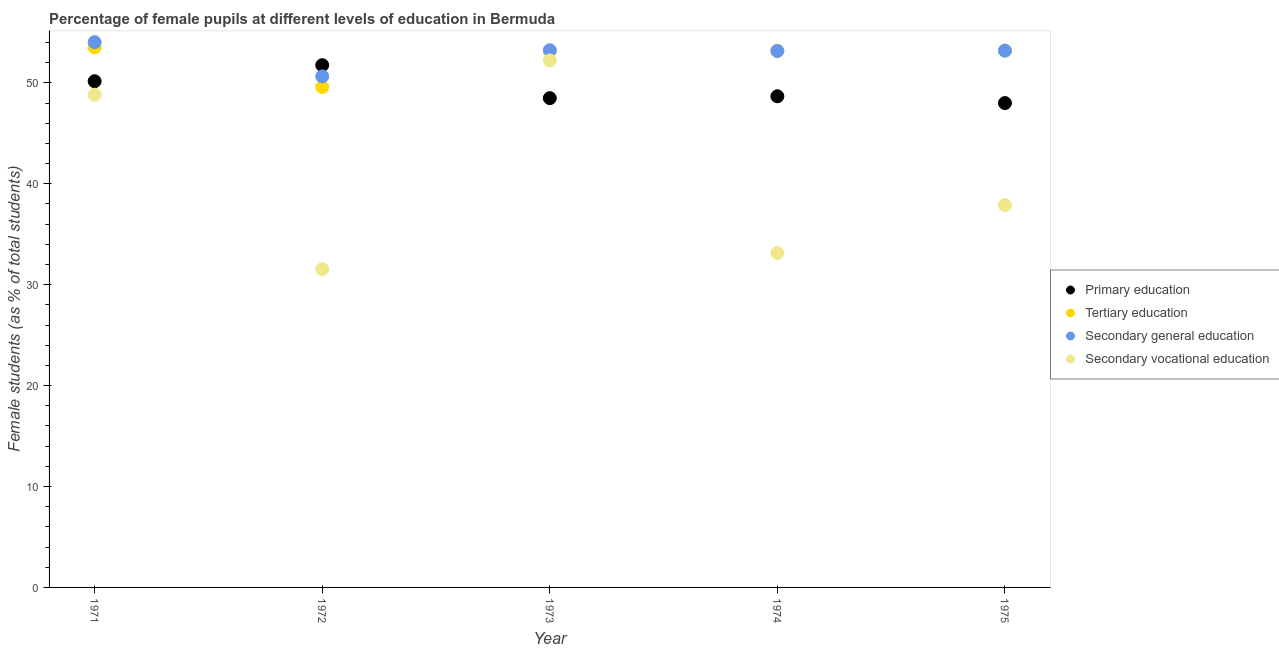How many different coloured dotlines are there?
Offer a terse response. 4. What is the percentage of female students in primary education in 1971?
Your answer should be very brief. 50.16. Across all years, what is the maximum percentage of female students in secondary vocational education?
Your response must be concise. 52.22. Across all years, what is the minimum percentage of female students in tertiary education?
Offer a very short reply. 49.59. In which year was the percentage of female students in secondary vocational education maximum?
Provide a succinct answer. 1973. What is the total percentage of female students in secondary vocational education in the graph?
Provide a short and direct response. 203.61. What is the difference between the percentage of female students in secondary education in 1973 and that in 1975?
Provide a short and direct response. 0.04. What is the difference between the percentage of female students in secondary vocational education in 1972 and the percentage of female students in tertiary education in 1971?
Provide a succinct answer. -21.98. What is the average percentage of female students in tertiary education per year?
Your answer should be very brief. 52.52. In the year 1974, what is the difference between the percentage of female students in secondary vocational education and percentage of female students in primary education?
Keep it short and to the point. -15.52. What is the ratio of the percentage of female students in primary education in 1973 to that in 1975?
Make the answer very short. 1.01. What is the difference between the highest and the second highest percentage of female students in secondary education?
Offer a very short reply. 0.8. What is the difference between the highest and the lowest percentage of female students in primary education?
Your response must be concise. 3.76. In how many years, is the percentage of female students in secondary education greater than the average percentage of female students in secondary education taken over all years?
Your answer should be very brief. 4. Is the sum of the percentage of female students in secondary vocational education in 1972 and 1974 greater than the maximum percentage of female students in primary education across all years?
Provide a succinct answer. Yes. Is the percentage of female students in tertiary education strictly greater than the percentage of female students in primary education over the years?
Offer a terse response. No. Is the percentage of female students in secondary vocational education strictly less than the percentage of female students in tertiary education over the years?
Keep it short and to the point. Yes. How many dotlines are there?
Keep it short and to the point. 4. What is the difference between two consecutive major ticks on the Y-axis?
Offer a terse response. 10. Does the graph contain grids?
Provide a succinct answer. No. How are the legend labels stacked?
Make the answer very short. Vertical. What is the title of the graph?
Your answer should be very brief. Percentage of female pupils at different levels of education in Bermuda. Does "Gender equality" appear as one of the legend labels in the graph?
Your response must be concise. No. What is the label or title of the Y-axis?
Your answer should be very brief. Female students (as % of total students). What is the Female students (as % of total students) of Primary education in 1971?
Ensure brevity in your answer.  50.16. What is the Female students (as % of total students) in Tertiary education in 1971?
Your response must be concise. 53.51. What is the Female students (as % of total students) of Secondary general education in 1971?
Give a very brief answer. 54.03. What is the Female students (as % of total students) of Secondary vocational education in 1971?
Your answer should be very brief. 48.82. What is the Female students (as % of total students) of Primary education in 1972?
Your answer should be compact. 51.75. What is the Female students (as % of total students) in Tertiary education in 1972?
Give a very brief answer. 49.59. What is the Female students (as % of total students) in Secondary general education in 1972?
Give a very brief answer. 50.64. What is the Female students (as % of total students) of Secondary vocational education in 1972?
Your answer should be compact. 31.54. What is the Female students (as % of total students) of Primary education in 1973?
Give a very brief answer. 48.49. What is the Female students (as % of total students) in Tertiary education in 1973?
Ensure brevity in your answer.  53.17. What is the Female students (as % of total students) in Secondary general education in 1973?
Provide a short and direct response. 53.23. What is the Female students (as % of total students) in Secondary vocational education in 1973?
Provide a short and direct response. 52.22. What is the Female students (as % of total students) of Primary education in 1974?
Ensure brevity in your answer.  48.67. What is the Female students (as % of total students) in Tertiary education in 1974?
Give a very brief answer. 53.16. What is the Female students (as % of total students) of Secondary general education in 1974?
Your response must be concise. 53.16. What is the Female students (as % of total students) of Secondary vocational education in 1974?
Provide a succinct answer. 33.15. What is the Female students (as % of total students) in Primary education in 1975?
Your response must be concise. 48. What is the Female students (as % of total students) in Tertiary education in 1975?
Make the answer very short. 53.19. What is the Female students (as % of total students) in Secondary general education in 1975?
Your answer should be compact. 53.19. What is the Female students (as % of total students) of Secondary vocational education in 1975?
Ensure brevity in your answer.  37.89. Across all years, what is the maximum Female students (as % of total students) in Primary education?
Ensure brevity in your answer.  51.75. Across all years, what is the maximum Female students (as % of total students) of Tertiary education?
Offer a terse response. 53.51. Across all years, what is the maximum Female students (as % of total students) in Secondary general education?
Your response must be concise. 54.03. Across all years, what is the maximum Female students (as % of total students) in Secondary vocational education?
Provide a short and direct response. 52.22. Across all years, what is the minimum Female students (as % of total students) of Primary education?
Your response must be concise. 48. Across all years, what is the minimum Female students (as % of total students) of Tertiary education?
Keep it short and to the point. 49.59. Across all years, what is the minimum Female students (as % of total students) in Secondary general education?
Keep it short and to the point. 50.64. Across all years, what is the minimum Female students (as % of total students) of Secondary vocational education?
Your answer should be compact. 31.54. What is the total Female students (as % of total students) of Primary education in the graph?
Offer a terse response. 247.07. What is the total Female students (as % of total students) of Tertiary education in the graph?
Make the answer very short. 262.62. What is the total Female students (as % of total students) in Secondary general education in the graph?
Ensure brevity in your answer.  264.26. What is the total Female students (as % of total students) in Secondary vocational education in the graph?
Your response must be concise. 203.61. What is the difference between the Female students (as % of total students) in Primary education in 1971 and that in 1972?
Provide a succinct answer. -1.59. What is the difference between the Female students (as % of total students) in Tertiary education in 1971 and that in 1972?
Your answer should be very brief. 3.93. What is the difference between the Female students (as % of total students) in Secondary general education in 1971 and that in 1972?
Your response must be concise. 3.39. What is the difference between the Female students (as % of total students) in Secondary vocational education in 1971 and that in 1972?
Your response must be concise. 17.29. What is the difference between the Female students (as % of total students) in Primary education in 1971 and that in 1973?
Offer a very short reply. 1.68. What is the difference between the Female students (as % of total students) of Tertiary education in 1971 and that in 1973?
Provide a succinct answer. 0.34. What is the difference between the Female students (as % of total students) of Secondary general education in 1971 and that in 1973?
Make the answer very short. 0.8. What is the difference between the Female students (as % of total students) in Secondary vocational education in 1971 and that in 1973?
Ensure brevity in your answer.  -3.4. What is the difference between the Female students (as % of total students) in Primary education in 1971 and that in 1974?
Provide a short and direct response. 1.49. What is the difference between the Female students (as % of total students) of Tertiary education in 1971 and that in 1974?
Your response must be concise. 0.35. What is the difference between the Female students (as % of total students) of Secondary general education in 1971 and that in 1974?
Ensure brevity in your answer.  0.87. What is the difference between the Female students (as % of total students) in Secondary vocational education in 1971 and that in 1974?
Provide a short and direct response. 15.67. What is the difference between the Female students (as % of total students) of Primary education in 1971 and that in 1975?
Ensure brevity in your answer.  2.16. What is the difference between the Female students (as % of total students) in Tertiary education in 1971 and that in 1975?
Your response must be concise. 0.32. What is the difference between the Female students (as % of total students) in Secondary general education in 1971 and that in 1975?
Keep it short and to the point. 0.84. What is the difference between the Female students (as % of total students) in Secondary vocational education in 1971 and that in 1975?
Offer a terse response. 10.94. What is the difference between the Female students (as % of total students) of Primary education in 1972 and that in 1973?
Offer a very short reply. 3.27. What is the difference between the Female students (as % of total students) in Tertiary education in 1972 and that in 1973?
Provide a short and direct response. -3.58. What is the difference between the Female students (as % of total students) of Secondary general education in 1972 and that in 1973?
Offer a very short reply. -2.59. What is the difference between the Female students (as % of total students) of Secondary vocational education in 1972 and that in 1973?
Give a very brief answer. -20.68. What is the difference between the Female students (as % of total students) in Primary education in 1972 and that in 1974?
Provide a succinct answer. 3.08. What is the difference between the Female students (as % of total students) in Tertiary education in 1972 and that in 1974?
Give a very brief answer. -3.58. What is the difference between the Female students (as % of total students) in Secondary general education in 1972 and that in 1974?
Keep it short and to the point. -2.52. What is the difference between the Female students (as % of total students) of Secondary vocational education in 1972 and that in 1974?
Ensure brevity in your answer.  -1.62. What is the difference between the Female students (as % of total students) of Primary education in 1972 and that in 1975?
Your answer should be compact. 3.76. What is the difference between the Female students (as % of total students) in Tertiary education in 1972 and that in 1975?
Your response must be concise. -3.61. What is the difference between the Female students (as % of total students) in Secondary general education in 1972 and that in 1975?
Make the answer very short. -2.55. What is the difference between the Female students (as % of total students) of Secondary vocational education in 1972 and that in 1975?
Offer a terse response. -6.35. What is the difference between the Female students (as % of total students) in Primary education in 1973 and that in 1974?
Provide a short and direct response. -0.18. What is the difference between the Female students (as % of total students) in Tertiary education in 1973 and that in 1974?
Provide a short and direct response. 0.01. What is the difference between the Female students (as % of total students) in Secondary general education in 1973 and that in 1974?
Your answer should be very brief. 0.07. What is the difference between the Female students (as % of total students) of Secondary vocational education in 1973 and that in 1974?
Make the answer very short. 19.07. What is the difference between the Female students (as % of total students) in Primary education in 1973 and that in 1975?
Offer a very short reply. 0.49. What is the difference between the Female students (as % of total students) in Tertiary education in 1973 and that in 1975?
Make the answer very short. -0.02. What is the difference between the Female students (as % of total students) in Secondary general education in 1973 and that in 1975?
Keep it short and to the point. 0.04. What is the difference between the Female students (as % of total students) in Secondary vocational education in 1973 and that in 1975?
Keep it short and to the point. 14.33. What is the difference between the Female students (as % of total students) of Primary education in 1974 and that in 1975?
Provide a succinct answer. 0.67. What is the difference between the Female students (as % of total students) in Tertiary education in 1974 and that in 1975?
Your response must be concise. -0.03. What is the difference between the Female students (as % of total students) of Secondary general education in 1974 and that in 1975?
Offer a terse response. -0.03. What is the difference between the Female students (as % of total students) of Secondary vocational education in 1974 and that in 1975?
Make the answer very short. -4.73. What is the difference between the Female students (as % of total students) in Primary education in 1971 and the Female students (as % of total students) in Tertiary education in 1972?
Your answer should be compact. 0.58. What is the difference between the Female students (as % of total students) in Primary education in 1971 and the Female students (as % of total students) in Secondary general education in 1972?
Offer a terse response. -0.48. What is the difference between the Female students (as % of total students) in Primary education in 1971 and the Female students (as % of total students) in Secondary vocational education in 1972?
Provide a short and direct response. 18.63. What is the difference between the Female students (as % of total students) in Tertiary education in 1971 and the Female students (as % of total students) in Secondary general education in 1972?
Your response must be concise. 2.87. What is the difference between the Female students (as % of total students) in Tertiary education in 1971 and the Female students (as % of total students) in Secondary vocational education in 1972?
Give a very brief answer. 21.98. What is the difference between the Female students (as % of total students) of Secondary general education in 1971 and the Female students (as % of total students) of Secondary vocational education in 1972?
Your answer should be very brief. 22.5. What is the difference between the Female students (as % of total students) in Primary education in 1971 and the Female students (as % of total students) in Tertiary education in 1973?
Keep it short and to the point. -3.01. What is the difference between the Female students (as % of total students) in Primary education in 1971 and the Female students (as % of total students) in Secondary general education in 1973?
Offer a very short reply. -3.07. What is the difference between the Female students (as % of total students) in Primary education in 1971 and the Female students (as % of total students) in Secondary vocational education in 1973?
Ensure brevity in your answer.  -2.06. What is the difference between the Female students (as % of total students) of Tertiary education in 1971 and the Female students (as % of total students) of Secondary general education in 1973?
Provide a short and direct response. 0.28. What is the difference between the Female students (as % of total students) in Tertiary education in 1971 and the Female students (as % of total students) in Secondary vocational education in 1973?
Give a very brief answer. 1.3. What is the difference between the Female students (as % of total students) of Secondary general education in 1971 and the Female students (as % of total students) of Secondary vocational education in 1973?
Your answer should be very brief. 1.81. What is the difference between the Female students (as % of total students) in Primary education in 1971 and the Female students (as % of total students) in Tertiary education in 1974?
Offer a terse response. -3. What is the difference between the Female students (as % of total students) in Primary education in 1971 and the Female students (as % of total students) in Secondary general education in 1974?
Ensure brevity in your answer.  -3. What is the difference between the Female students (as % of total students) in Primary education in 1971 and the Female students (as % of total students) in Secondary vocational education in 1974?
Offer a very short reply. 17.01. What is the difference between the Female students (as % of total students) of Tertiary education in 1971 and the Female students (as % of total students) of Secondary general education in 1974?
Offer a very short reply. 0.35. What is the difference between the Female students (as % of total students) of Tertiary education in 1971 and the Female students (as % of total students) of Secondary vocational education in 1974?
Your answer should be compact. 20.36. What is the difference between the Female students (as % of total students) in Secondary general education in 1971 and the Female students (as % of total students) in Secondary vocational education in 1974?
Keep it short and to the point. 20.88. What is the difference between the Female students (as % of total students) of Primary education in 1971 and the Female students (as % of total students) of Tertiary education in 1975?
Provide a short and direct response. -3.03. What is the difference between the Female students (as % of total students) in Primary education in 1971 and the Female students (as % of total students) in Secondary general education in 1975?
Give a very brief answer. -3.03. What is the difference between the Female students (as % of total students) in Primary education in 1971 and the Female students (as % of total students) in Secondary vocational education in 1975?
Offer a terse response. 12.28. What is the difference between the Female students (as % of total students) in Tertiary education in 1971 and the Female students (as % of total students) in Secondary general education in 1975?
Your answer should be very brief. 0.32. What is the difference between the Female students (as % of total students) in Tertiary education in 1971 and the Female students (as % of total students) in Secondary vocational education in 1975?
Provide a short and direct response. 15.63. What is the difference between the Female students (as % of total students) in Secondary general education in 1971 and the Female students (as % of total students) in Secondary vocational education in 1975?
Your answer should be very brief. 16.15. What is the difference between the Female students (as % of total students) in Primary education in 1972 and the Female students (as % of total students) in Tertiary education in 1973?
Your answer should be very brief. -1.42. What is the difference between the Female students (as % of total students) in Primary education in 1972 and the Female students (as % of total students) in Secondary general education in 1973?
Keep it short and to the point. -1.48. What is the difference between the Female students (as % of total students) in Primary education in 1972 and the Female students (as % of total students) in Secondary vocational education in 1973?
Provide a short and direct response. -0.46. What is the difference between the Female students (as % of total students) of Tertiary education in 1972 and the Female students (as % of total students) of Secondary general education in 1973?
Provide a succinct answer. -3.65. What is the difference between the Female students (as % of total students) in Tertiary education in 1972 and the Female students (as % of total students) in Secondary vocational education in 1973?
Provide a succinct answer. -2.63. What is the difference between the Female students (as % of total students) of Secondary general education in 1972 and the Female students (as % of total students) of Secondary vocational education in 1973?
Provide a short and direct response. -1.57. What is the difference between the Female students (as % of total students) of Primary education in 1972 and the Female students (as % of total students) of Tertiary education in 1974?
Offer a very short reply. -1.41. What is the difference between the Female students (as % of total students) of Primary education in 1972 and the Female students (as % of total students) of Secondary general education in 1974?
Offer a terse response. -1.41. What is the difference between the Female students (as % of total students) of Primary education in 1972 and the Female students (as % of total students) of Secondary vocational education in 1974?
Your response must be concise. 18.6. What is the difference between the Female students (as % of total students) in Tertiary education in 1972 and the Female students (as % of total students) in Secondary general education in 1974?
Give a very brief answer. -3.58. What is the difference between the Female students (as % of total students) in Tertiary education in 1972 and the Female students (as % of total students) in Secondary vocational education in 1974?
Make the answer very short. 16.43. What is the difference between the Female students (as % of total students) of Secondary general education in 1972 and the Female students (as % of total students) of Secondary vocational education in 1974?
Your answer should be compact. 17.49. What is the difference between the Female students (as % of total students) in Primary education in 1972 and the Female students (as % of total students) in Tertiary education in 1975?
Your answer should be very brief. -1.44. What is the difference between the Female students (as % of total students) in Primary education in 1972 and the Female students (as % of total students) in Secondary general education in 1975?
Offer a very short reply. -1.44. What is the difference between the Female students (as % of total students) in Primary education in 1972 and the Female students (as % of total students) in Secondary vocational education in 1975?
Your response must be concise. 13.87. What is the difference between the Female students (as % of total students) in Tertiary education in 1972 and the Female students (as % of total students) in Secondary general education in 1975?
Provide a short and direct response. -3.61. What is the difference between the Female students (as % of total students) in Tertiary education in 1972 and the Female students (as % of total students) in Secondary vocational education in 1975?
Give a very brief answer. 11.7. What is the difference between the Female students (as % of total students) in Secondary general education in 1972 and the Female students (as % of total students) in Secondary vocational education in 1975?
Your response must be concise. 12.76. What is the difference between the Female students (as % of total students) of Primary education in 1973 and the Female students (as % of total students) of Tertiary education in 1974?
Offer a terse response. -4.68. What is the difference between the Female students (as % of total students) of Primary education in 1973 and the Female students (as % of total students) of Secondary general education in 1974?
Offer a very short reply. -4.68. What is the difference between the Female students (as % of total students) of Primary education in 1973 and the Female students (as % of total students) of Secondary vocational education in 1974?
Your response must be concise. 15.33. What is the difference between the Female students (as % of total students) in Tertiary education in 1973 and the Female students (as % of total students) in Secondary general education in 1974?
Offer a terse response. 0.01. What is the difference between the Female students (as % of total students) of Tertiary education in 1973 and the Female students (as % of total students) of Secondary vocational education in 1974?
Provide a short and direct response. 20.02. What is the difference between the Female students (as % of total students) of Secondary general education in 1973 and the Female students (as % of total students) of Secondary vocational education in 1974?
Give a very brief answer. 20.08. What is the difference between the Female students (as % of total students) of Primary education in 1973 and the Female students (as % of total students) of Tertiary education in 1975?
Offer a very short reply. -4.71. What is the difference between the Female students (as % of total students) of Primary education in 1973 and the Female students (as % of total students) of Secondary general education in 1975?
Offer a terse response. -4.71. What is the difference between the Female students (as % of total students) in Primary education in 1973 and the Female students (as % of total students) in Secondary vocational education in 1975?
Provide a succinct answer. 10.6. What is the difference between the Female students (as % of total students) of Tertiary education in 1973 and the Female students (as % of total students) of Secondary general education in 1975?
Ensure brevity in your answer.  -0.02. What is the difference between the Female students (as % of total students) of Tertiary education in 1973 and the Female students (as % of total students) of Secondary vocational education in 1975?
Give a very brief answer. 15.28. What is the difference between the Female students (as % of total students) in Secondary general education in 1973 and the Female students (as % of total students) in Secondary vocational education in 1975?
Your answer should be very brief. 15.35. What is the difference between the Female students (as % of total students) in Primary education in 1974 and the Female students (as % of total students) in Tertiary education in 1975?
Provide a short and direct response. -4.52. What is the difference between the Female students (as % of total students) in Primary education in 1974 and the Female students (as % of total students) in Secondary general education in 1975?
Ensure brevity in your answer.  -4.52. What is the difference between the Female students (as % of total students) in Primary education in 1974 and the Female students (as % of total students) in Secondary vocational education in 1975?
Your response must be concise. 10.79. What is the difference between the Female students (as % of total students) in Tertiary education in 1974 and the Female students (as % of total students) in Secondary general education in 1975?
Your answer should be very brief. -0.03. What is the difference between the Female students (as % of total students) in Tertiary education in 1974 and the Female students (as % of total students) in Secondary vocational education in 1975?
Ensure brevity in your answer.  15.28. What is the difference between the Female students (as % of total students) of Secondary general education in 1974 and the Female students (as % of total students) of Secondary vocational education in 1975?
Offer a terse response. 15.28. What is the average Female students (as % of total students) of Primary education per year?
Your response must be concise. 49.41. What is the average Female students (as % of total students) in Tertiary education per year?
Offer a terse response. 52.52. What is the average Female students (as % of total students) in Secondary general education per year?
Offer a terse response. 52.85. What is the average Female students (as % of total students) of Secondary vocational education per year?
Give a very brief answer. 40.72. In the year 1971, what is the difference between the Female students (as % of total students) of Primary education and Female students (as % of total students) of Tertiary education?
Keep it short and to the point. -3.35. In the year 1971, what is the difference between the Female students (as % of total students) of Primary education and Female students (as % of total students) of Secondary general education?
Your response must be concise. -3.87. In the year 1971, what is the difference between the Female students (as % of total students) of Primary education and Female students (as % of total students) of Secondary vocational education?
Keep it short and to the point. 1.34. In the year 1971, what is the difference between the Female students (as % of total students) of Tertiary education and Female students (as % of total students) of Secondary general education?
Ensure brevity in your answer.  -0.52. In the year 1971, what is the difference between the Female students (as % of total students) of Tertiary education and Female students (as % of total students) of Secondary vocational education?
Keep it short and to the point. 4.69. In the year 1971, what is the difference between the Female students (as % of total students) of Secondary general education and Female students (as % of total students) of Secondary vocational education?
Keep it short and to the point. 5.21. In the year 1972, what is the difference between the Female students (as % of total students) in Primary education and Female students (as % of total students) in Tertiary education?
Make the answer very short. 2.17. In the year 1972, what is the difference between the Female students (as % of total students) of Primary education and Female students (as % of total students) of Secondary general education?
Offer a terse response. 1.11. In the year 1972, what is the difference between the Female students (as % of total students) of Primary education and Female students (as % of total students) of Secondary vocational education?
Make the answer very short. 20.22. In the year 1972, what is the difference between the Female students (as % of total students) in Tertiary education and Female students (as % of total students) in Secondary general education?
Keep it short and to the point. -1.06. In the year 1972, what is the difference between the Female students (as % of total students) of Tertiary education and Female students (as % of total students) of Secondary vocational education?
Your answer should be compact. 18.05. In the year 1972, what is the difference between the Female students (as % of total students) in Secondary general education and Female students (as % of total students) in Secondary vocational education?
Ensure brevity in your answer.  19.11. In the year 1973, what is the difference between the Female students (as % of total students) of Primary education and Female students (as % of total students) of Tertiary education?
Your answer should be very brief. -4.68. In the year 1973, what is the difference between the Female students (as % of total students) in Primary education and Female students (as % of total students) in Secondary general education?
Ensure brevity in your answer.  -4.75. In the year 1973, what is the difference between the Female students (as % of total students) in Primary education and Female students (as % of total students) in Secondary vocational education?
Your answer should be compact. -3.73. In the year 1973, what is the difference between the Female students (as % of total students) of Tertiary education and Female students (as % of total students) of Secondary general education?
Your answer should be very brief. -0.06. In the year 1973, what is the difference between the Female students (as % of total students) of Tertiary education and Female students (as % of total students) of Secondary vocational education?
Keep it short and to the point. 0.95. In the year 1973, what is the difference between the Female students (as % of total students) of Secondary general education and Female students (as % of total students) of Secondary vocational education?
Provide a short and direct response. 1.01. In the year 1974, what is the difference between the Female students (as % of total students) in Primary education and Female students (as % of total students) in Tertiary education?
Your answer should be very brief. -4.49. In the year 1974, what is the difference between the Female students (as % of total students) of Primary education and Female students (as % of total students) of Secondary general education?
Your answer should be compact. -4.49. In the year 1974, what is the difference between the Female students (as % of total students) of Primary education and Female students (as % of total students) of Secondary vocational education?
Make the answer very short. 15.52. In the year 1974, what is the difference between the Female students (as % of total students) in Tertiary education and Female students (as % of total students) in Secondary vocational education?
Offer a terse response. 20.01. In the year 1974, what is the difference between the Female students (as % of total students) in Secondary general education and Female students (as % of total students) in Secondary vocational education?
Your response must be concise. 20.01. In the year 1975, what is the difference between the Female students (as % of total students) of Primary education and Female students (as % of total students) of Tertiary education?
Make the answer very short. -5.19. In the year 1975, what is the difference between the Female students (as % of total students) in Primary education and Female students (as % of total students) in Secondary general education?
Offer a very short reply. -5.19. In the year 1975, what is the difference between the Female students (as % of total students) in Primary education and Female students (as % of total students) in Secondary vocational education?
Give a very brief answer. 10.11. In the year 1975, what is the difference between the Female students (as % of total students) of Tertiary education and Female students (as % of total students) of Secondary general education?
Offer a terse response. 0. In the year 1975, what is the difference between the Female students (as % of total students) in Tertiary education and Female students (as % of total students) in Secondary vocational education?
Offer a very short reply. 15.31. In the year 1975, what is the difference between the Female students (as % of total students) in Secondary general education and Female students (as % of total students) in Secondary vocational education?
Your answer should be compact. 15.31. What is the ratio of the Female students (as % of total students) in Primary education in 1971 to that in 1972?
Offer a terse response. 0.97. What is the ratio of the Female students (as % of total students) in Tertiary education in 1971 to that in 1972?
Your answer should be compact. 1.08. What is the ratio of the Female students (as % of total students) in Secondary general education in 1971 to that in 1972?
Offer a terse response. 1.07. What is the ratio of the Female students (as % of total students) in Secondary vocational education in 1971 to that in 1972?
Your answer should be very brief. 1.55. What is the ratio of the Female students (as % of total students) in Primary education in 1971 to that in 1973?
Offer a terse response. 1.03. What is the ratio of the Female students (as % of total students) in Secondary vocational education in 1971 to that in 1973?
Provide a succinct answer. 0.93. What is the ratio of the Female students (as % of total students) of Primary education in 1971 to that in 1974?
Offer a terse response. 1.03. What is the ratio of the Female students (as % of total students) in Tertiary education in 1971 to that in 1974?
Provide a short and direct response. 1.01. What is the ratio of the Female students (as % of total students) in Secondary general education in 1971 to that in 1974?
Your answer should be compact. 1.02. What is the ratio of the Female students (as % of total students) of Secondary vocational education in 1971 to that in 1974?
Keep it short and to the point. 1.47. What is the ratio of the Female students (as % of total students) in Primary education in 1971 to that in 1975?
Your response must be concise. 1.05. What is the ratio of the Female students (as % of total students) in Tertiary education in 1971 to that in 1975?
Your answer should be compact. 1.01. What is the ratio of the Female students (as % of total students) of Secondary general education in 1971 to that in 1975?
Give a very brief answer. 1.02. What is the ratio of the Female students (as % of total students) in Secondary vocational education in 1971 to that in 1975?
Offer a terse response. 1.29. What is the ratio of the Female students (as % of total students) in Primary education in 1972 to that in 1973?
Ensure brevity in your answer.  1.07. What is the ratio of the Female students (as % of total students) of Tertiary education in 1972 to that in 1973?
Ensure brevity in your answer.  0.93. What is the ratio of the Female students (as % of total students) in Secondary general education in 1972 to that in 1973?
Give a very brief answer. 0.95. What is the ratio of the Female students (as % of total students) in Secondary vocational education in 1972 to that in 1973?
Your answer should be very brief. 0.6. What is the ratio of the Female students (as % of total students) of Primary education in 1972 to that in 1974?
Make the answer very short. 1.06. What is the ratio of the Female students (as % of total students) in Tertiary education in 1972 to that in 1974?
Ensure brevity in your answer.  0.93. What is the ratio of the Female students (as % of total students) of Secondary general education in 1972 to that in 1974?
Make the answer very short. 0.95. What is the ratio of the Female students (as % of total students) of Secondary vocational education in 1972 to that in 1974?
Keep it short and to the point. 0.95. What is the ratio of the Female students (as % of total students) of Primary education in 1972 to that in 1975?
Ensure brevity in your answer.  1.08. What is the ratio of the Female students (as % of total students) of Tertiary education in 1972 to that in 1975?
Provide a short and direct response. 0.93. What is the ratio of the Female students (as % of total students) of Secondary general education in 1972 to that in 1975?
Provide a short and direct response. 0.95. What is the ratio of the Female students (as % of total students) of Secondary vocational education in 1972 to that in 1975?
Give a very brief answer. 0.83. What is the ratio of the Female students (as % of total students) in Tertiary education in 1973 to that in 1974?
Make the answer very short. 1. What is the ratio of the Female students (as % of total students) of Secondary general education in 1973 to that in 1974?
Give a very brief answer. 1. What is the ratio of the Female students (as % of total students) of Secondary vocational education in 1973 to that in 1974?
Make the answer very short. 1.58. What is the ratio of the Female students (as % of total students) of Primary education in 1973 to that in 1975?
Your answer should be compact. 1.01. What is the ratio of the Female students (as % of total students) in Secondary vocational education in 1973 to that in 1975?
Ensure brevity in your answer.  1.38. What is the ratio of the Female students (as % of total students) in Secondary general education in 1974 to that in 1975?
Ensure brevity in your answer.  1. What is the ratio of the Female students (as % of total students) in Secondary vocational education in 1974 to that in 1975?
Offer a very short reply. 0.88. What is the difference between the highest and the second highest Female students (as % of total students) of Primary education?
Give a very brief answer. 1.59. What is the difference between the highest and the second highest Female students (as % of total students) of Tertiary education?
Keep it short and to the point. 0.32. What is the difference between the highest and the second highest Female students (as % of total students) in Secondary general education?
Make the answer very short. 0.8. What is the difference between the highest and the second highest Female students (as % of total students) of Secondary vocational education?
Make the answer very short. 3.4. What is the difference between the highest and the lowest Female students (as % of total students) in Primary education?
Keep it short and to the point. 3.76. What is the difference between the highest and the lowest Female students (as % of total students) in Tertiary education?
Your response must be concise. 3.93. What is the difference between the highest and the lowest Female students (as % of total students) of Secondary general education?
Give a very brief answer. 3.39. What is the difference between the highest and the lowest Female students (as % of total students) in Secondary vocational education?
Your answer should be very brief. 20.68. 